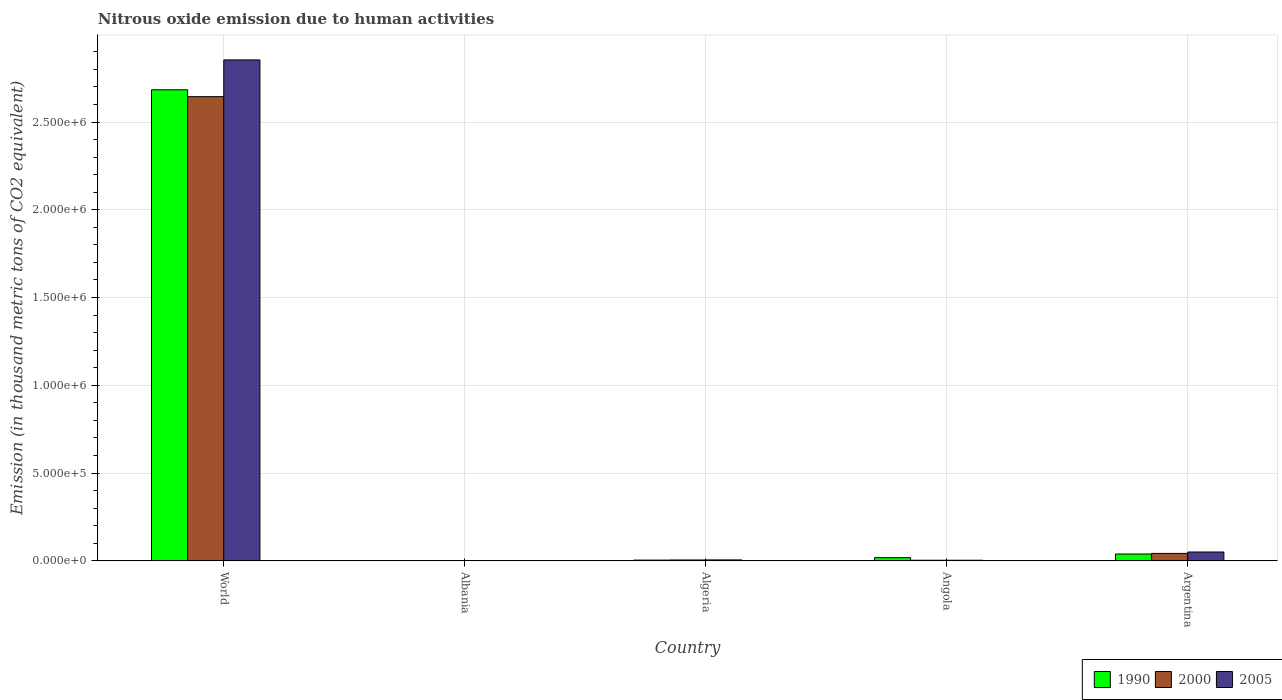How many groups of bars are there?
Offer a terse response. 5. Are the number of bars on each tick of the X-axis equal?
Provide a short and direct response. Yes. How many bars are there on the 3rd tick from the left?
Your answer should be very brief. 3. How many bars are there on the 3rd tick from the right?
Your response must be concise. 3. In how many cases, is the number of bars for a given country not equal to the number of legend labels?
Give a very brief answer. 0. What is the amount of nitrous oxide emitted in 1990 in Algeria?
Offer a terse response. 3867.6. Across all countries, what is the maximum amount of nitrous oxide emitted in 2005?
Offer a terse response. 2.85e+06. Across all countries, what is the minimum amount of nitrous oxide emitted in 2000?
Keep it short and to the point. 1270.7. In which country was the amount of nitrous oxide emitted in 2000 maximum?
Make the answer very short. World. In which country was the amount of nitrous oxide emitted in 1990 minimum?
Make the answer very short. Albania. What is the total amount of nitrous oxide emitted in 1990 in the graph?
Provide a short and direct response. 2.75e+06. What is the difference between the amount of nitrous oxide emitted in 2005 in Argentina and that in World?
Offer a terse response. -2.80e+06. What is the difference between the amount of nitrous oxide emitted in 1990 in Argentina and the amount of nitrous oxide emitted in 2005 in Angola?
Give a very brief answer. 3.54e+04. What is the average amount of nitrous oxide emitted in 2005 per country?
Keep it short and to the point. 5.83e+05. What is the difference between the amount of nitrous oxide emitted of/in 2005 and amount of nitrous oxide emitted of/in 2000 in Argentina?
Offer a terse response. 8004.7. In how many countries, is the amount of nitrous oxide emitted in 2000 greater than 2000000 thousand metric tons?
Ensure brevity in your answer.  1. What is the ratio of the amount of nitrous oxide emitted in 2005 in Albania to that in Angola?
Your response must be concise. 0.34. What is the difference between the highest and the second highest amount of nitrous oxide emitted in 2000?
Offer a very short reply. 2.64e+06. What is the difference between the highest and the lowest amount of nitrous oxide emitted in 1990?
Your answer should be compact. 2.68e+06. What does the 3rd bar from the left in Albania represents?
Make the answer very short. 2005. Is it the case that in every country, the sum of the amount of nitrous oxide emitted in 2000 and amount of nitrous oxide emitted in 1990 is greater than the amount of nitrous oxide emitted in 2005?
Provide a succinct answer. Yes. How many bars are there?
Your answer should be very brief. 15. Does the graph contain grids?
Provide a short and direct response. Yes. How many legend labels are there?
Offer a very short reply. 3. How are the legend labels stacked?
Your response must be concise. Horizontal. What is the title of the graph?
Ensure brevity in your answer.  Nitrous oxide emission due to human activities. What is the label or title of the Y-axis?
Your response must be concise. Emission (in thousand metric tons of CO2 equivalent). What is the Emission (in thousand metric tons of CO2 equivalent) of 1990 in World?
Your response must be concise. 2.68e+06. What is the Emission (in thousand metric tons of CO2 equivalent) in 2000 in World?
Provide a short and direct response. 2.64e+06. What is the Emission (in thousand metric tons of CO2 equivalent) of 2005 in World?
Your response must be concise. 2.85e+06. What is the Emission (in thousand metric tons of CO2 equivalent) in 1990 in Albania?
Your answer should be very brief. 1276.4. What is the Emission (in thousand metric tons of CO2 equivalent) of 2000 in Albania?
Your response must be concise. 1270.7. What is the Emission (in thousand metric tons of CO2 equivalent) of 2005 in Albania?
Your answer should be compact. 1039.6. What is the Emission (in thousand metric tons of CO2 equivalent) of 1990 in Algeria?
Provide a short and direct response. 3867.6. What is the Emission (in thousand metric tons of CO2 equivalent) of 2000 in Algeria?
Offer a terse response. 4507.1. What is the Emission (in thousand metric tons of CO2 equivalent) of 2005 in Algeria?
Your answer should be compact. 4917. What is the Emission (in thousand metric tons of CO2 equivalent) of 1990 in Angola?
Give a very brief answer. 1.77e+04. What is the Emission (in thousand metric tons of CO2 equivalent) in 2000 in Angola?
Your answer should be very brief. 3005.3. What is the Emission (in thousand metric tons of CO2 equivalent) of 2005 in Angola?
Keep it short and to the point. 3056.7. What is the Emission (in thousand metric tons of CO2 equivalent) of 1990 in Argentina?
Make the answer very short. 3.85e+04. What is the Emission (in thousand metric tons of CO2 equivalent) in 2000 in Argentina?
Offer a terse response. 4.20e+04. What is the Emission (in thousand metric tons of CO2 equivalent) in 2005 in Argentina?
Provide a short and direct response. 5.00e+04. Across all countries, what is the maximum Emission (in thousand metric tons of CO2 equivalent) of 1990?
Make the answer very short. 2.68e+06. Across all countries, what is the maximum Emission (in thousand metric tons of CO2 equivalent) of 2000?
Your response must be concise. 2.64e+06. Across all countries, what is the maximum Emission (in thousand metric tons of CO2 equivalent) of 2005?
Provide a succinct answer. 2.85e+06. Across all countries, what is the minimum Emission (in thousand metric tons of CO2 equivalent) of 1990?
Ensure brevity in your answer.  1276.4. Across all countries, what is the minimum Emission (in thousand metric tons of CO2 equivalent) in 2000?
Your answer should be compact. 1270.7. Across all countries, what is the minimum Emission (in thousand metric tons of CO2 equivalent) in 2005?
Give a very brief answer. 1039.6. What is the total Emission (in thousand metric tons of CO2 equivalent) in 1990 in the graph?
Your answer should be compact. 2.75e+06. What is the total Emission (in thousand metric tons of CO2 equivalent) in 2000 in the graph?
Your answer should be very brief. 2.70e+06. What is the total Emission (in thousand metric tons of CO2 equivalent) in 2005 in the graph?
Ensure brevity in your answer.  2.91e+06. What is the difference between the Emission (in thousand metric tons of CO2 equivalent) in 1990 in World and that in Albania?
Provide a short and direct response. 2.68e+06. What is the difference between the Emission (in thousand metric tons of CO2 equivalent) of 2000 in World and that in Albania?
Offer a terse response. 2.64e+06. What is the difference between the Emission (in thousand metric tons of CO2 equivalent) in 2005 in World and that in Albania?
Offer a very short reply. 2.85e+06. What is the difference between the Emission (in thousand metric tons of CO2 equivalent) of 1990 in World and that in Algeria?
Provide a short and direct response. 2.68e+06. What is the difference between the Emission (in thousand metric tons of CO2 equivalent) of 2000 in World and that in Algeria?
Give a very brief answer. 2.64e+06. What is the difference between the Emission (in thousand metric tons of CO2 equivalent) of 2005 in World and that in Algeria?
Provide a short and direct response. 2.85e+06. What is the difference between the Emission (in thousand metric tons of CO2 equivalent) in 1990 in World and that in Angola?
Your answer should be very brief. 2.67e+06. What is the difference between the Emission (in thousand metric tons of CO2 equivalent) in 2000 in World and that in Angola?
Ensure brevity in your answer.  2.64e+06. What is the difference between the Emission (in thousand metric tons of CO2 equivalent) in 2005 in World and that in Angola?
Your answer should be compact. 2.85e+06. What is the difference between the Emission (in thousand metric tons of CO2 equivalent) of 1990 in World and that in Argentina?
Provide a succinct answer. 2.65e+06. What is the difference between the Emission (in thousand metric tons of CO2 equivalent) of 2000 in World and that in Argentina?
Your response must be concise. 2.60e+06. What is the difference between the Emission (in thousand metric tons of CO2 equivalent) in 2005 in World and that in Argentina?
Keep it short and to the point. 2.80e+06. What is the difference between the Emission (in thousand metric tons of CO2 equivalent) in 1990 in Albania and that in Algeria?
Offer a terse response. -2591.2. What is the difference between the Emission (in thousand metric tons of CO2 equivalent) of 2000 in Albania and that in Algeria?
Keep it short and to the point. -3236.4. What is the difference between the Emission (in thousand metric tons of CO2 equivalent) in 2005 in Albania and that in Algeria?
Keep it short and to the point. -3877.4. What is the difference between the Emission (in thousand metric tons of CO2 equivalent) in 1990 in Albania and that in Angola?
Your answer should be very brief. -1.65e+04. What is the difference between the Emission (in thousand metric tons of CO2 equivalent) in 2000 in Albania and that in Angola?
Ensure brevity in your answer.  -1734.6. What is the difference between the Emission (in thousand metric tons of CO2 equivalent) in 2005 in Albania and that in Angola?
Make the answer very short. -2017.1. What is the difference between the Emission (in thousand metric tons of CO2 equivalent) in 1990 in Albania and that in Argentina?
Ensure brevity in your answer.  -3.72e+04. What is the difference between the Emission (in thousand metric tons of CO2 equivalent) of 2000 in Albania and that in Argentina?
Your response must be concise. -4.07e+04. What is the difference between the Emission (in thousand metric tons of CO2 equivalent) in 2005 in Albania and that in Argentina?
Your answer should be very brief. -4.89e+04. What is the difference between the Emission (in thousand metric tons of CO2 equivalent) in 1990 in Algeria and that in Angola?
Your answer should be very brief. -1.39e+04. What is the difference between the Emission (in thousand metric tons of CO2 equivalent) of 2000 in Algeria and that in Angola?
Keep it short and to the point. 1501.8. What is the difference between the Emission (in thousand metric tons of CO2 equivalent) of 2005 in Algeria and that in Angola?
Offer a terse response. 1860.3. What is the difference between the Emission (in thousand metric tons of CO2 equivalent) of 1990 in Algeria and that in Argentina?
Your answer should be compact. -3.46e+04. What is the difference between the Emission (in thousand metric tons of CO2 equivalent) in 2000 in Algeria and that in Argentina?
Your answer should be compact. -3.74e+04. What is the difference between the Emission (in thousand metric tons of CO2 equivalent) of 2005 in Algeria and that in Argentina?
Your response must be concise. -4.50e+04. What is the difference between the Emission (in thousand metric tons of CO2 equivalent) of 1990 in Angola and that in Argentina?
Provide a short and direct response. -2.07e+04. What is the difference between the Emission (in thousand metric tons of CO2 equivalent) in 2000 in Angola and that in Argentina?
Provide a short and direct response. -3.89e+04. What is the difference between the Emission (in thousand metric tons of CO2 equivalent) in 2005 in Angola and that in Argentina?
Ensure brevity in your answer.  -4.69e+04. What is the difference between the Emission (in thousand metric tons of CO2 equivalent) in 1990 in World and the Emission (in thousand metric tons of CO2 equivalent) in 2000 in Albania?
Keep it short and to the point. 2.68e+06. What is the difference between the Emission (in thousand metric tons of CO2 equivalent) of 1990 in World and the Emission (in thousand metric tons of CO2 equivalent) of 2005 in Albania?
Ensure brevity in your answer.  2.68e+06. What is the difference between the Emission (in thousand metric tons of CO2 equivalent) in 2000 in World and the Emission (in thousand metric tons of CO2 equivalent) in 2005 in Albania?
Keep it short and to the point. 2.64e+06. What is the difference between the Emission (in thousand metric tons of CO2 equivalent) in 1990 in World and the Emission (in thousand metric tons of CO2 equivalent) in 2000 in Algeria?
Offer a very short reply. 2.68e+06. What is the difference between the Emission (in thousand metric tons of CO2 equivalent) in 1990 in World and the Emission (in thousand metric tons of CO2 equivalent) in 2005 in Algeria?
Offer a terse response. 2.68e+06. What is the difference between the Emission (in thousand metric tons of CO2 equivalent) of 2000 in World and the Emission (in thousand metric tons of CO2 equivalent) of 2005 in Algeria?
Your answer should be very brief. 2.64e+06. What is the difference between the Emission (in thousand metric tons of CO2 equivalent) of 1990 in World and the Emission (in thousand metric tons of CO2 equivalent) of 2000 in Angola?
Give a very brief answer. 2.68e+06. What is the difference between the Emission (in thousand metric tons of CO2 equivalent) in 1990 in World and the Emission (in thousand metric tons of CO2 equivalent) in 2005 in Angola?
Your response must be concise. 2.68e+06. What is the difference between the Emission (in thousand metric tons of CO2 equivalent) of 2000 in World and the Emission (in thousand metric tons of CO2 equivalent) of 2005 in Angola?
Provide a short and direct response. 2.64e+06. What is the difference between the Emission (in thousand metric tons of CO2 equivalent) in 1990 in World and the Emission (in thousand metric tons of CO2 equivalent) in 2000 in Argentina?
Make the answer very short. 2.64e+06. What is the difference between the Emission (in thousand metric tons of CO2 equivalent) in 1990 in World and the Emission (in thousand metric tons of CO2 equivalent) in 2005 in Argentina?
Ensure brevity in your answer.  2.63e+06. What is the difference between the Emission (in thousand metric tons of CO2 equivalent) of 2000 in World and the Emission (in thousand metric tons of CO2 equivalent) of 2005 in Argentina?
Your response must be concise. 2.59e+06. What is the difference between the Emission (in thousand metric tons of CO2 equivalent) of 1990 in Albania and the Emission (in thousand metric tons of CO2 equivalent) of 2000 in Algeria?
Provide a short and direct response. -3230.7. What is the difference between the Emission (in thousand metric tons of CO2 equivalent) of 1990 in Albania and the Emission (in thousand metric tons of CO2 equivalent) of 2005 in Algeria?
Your response must be concise. -3640.6. What is the difference between the Emission (in thousand metric tons of CO2 equivalent) in 2000 in Albania and the Emission (in thousand metric tons of CO2 equivalent) in 2005 in Algeria?
Give a very brief answer. -3646.3. What is the difference between the Emission (in thousand metric tons of CO2 equivalent) of 1990 in Albania and the Emission (in thousand metric tons of CO2 equivalent) of 2000 in Angola?
Provide a short and direct response. -1728.9. What is the difference between the Emission (in thousand metric tons of CO2 equivalent) in 1990 in Albania and the Emission (in thousand metric tons of CO2 equivalent) in 2005 in Angola?
Ensure brevity in your answer.  -1780.3. What is the difference between the Emission (in thousand metric tons of CO2 equivalent) in 2000 in Albania and the Emission (in thousand metric tons of CO2 equivalent) in 2005 in Angola?
Give a very brief answer. -1786. What is the difference between the Emission (in thousand metric tons of CO2 equivalent) of 1990 in Albania and the Emission (in thousand metric tons of CO2 equivalent) of 2000 in Argentina?
Your answer should be very brief. -4.07e+04. What is the difference between the Emission (in thousand metric tons of CO2 equivalent) of 1990 in Albania and the Emission (in thousand metric tons of CO2 equivalent) of 2005 in Argentina?
Make the answer very short. -4.87e+04. What is the difference between the Emission (in thousand metric tons of CO2 equivalent) in 2000 in Albania and the Emission (in thousand metric tons of CO2 equivalent) in 2005 in Argentina?
Ensure brevity in your answer.  -4.87e+04. What is the difference between the Emission (in thousand metric tons of CO2 equivalent) of 1990 in Algeria and the Emission (in thousand metric tons of CO2 equivalent) of 2000 in Angola?
Offer a terse response. 862.3. What is the difference between the Emission (in thousand metric tons of CO2 equivalent) of 1990 in Algeria and the Emission (in thousand metric tons of CO2 equivalent) of 2005 in Angola?
Ensure brevity in your answer.  810.9. What is the difference between the Emission (in thousand metric tons of CO2 equivalent) of 2000 in Algeria and the Emission (in thousand metric tons of CO2 equivalent) of 2005 in Angola?
Provide a short and direct response. 1450.4. What is the difference between the Emission (in thousand metric tons of CO2 equivalent) in 1990 in Algeria and the Emission (in thousand metric tons of CO2 equivalent) in 2000 in Argentina?
Your response must be concise. -3.81e+04. What is the difference between the Emission (in thousand metric tons of CO2 equivalent) in 1990 in Algeria and the Emission (in thousand metric tons of CO2 equivalent) in 2005 in Argentina?
Provide a succinct answer. -4.61e+04. What is the difference between the Emission (in thousand metric tons of CO2 equivalent) in 2000 in Algeria and the Emission (in thousand metric tons of CO2 equivalent) in 2005 in Argentina?
Offer a terse response. -4.54e+04. What is the difference between the Emission (in thousand metric tons of CO2 equivalent) of 1990 in Angola and the Emission (in thousand metric tons of CO2 equivalent) of 2000 in Argentina?
Provide a short and direct response. -2.42e+04. What is the difference between the Emission (in thousand metric tons of CO2 equivalent) of 1990 in Angola and the Emission (in thousand metric tons of CO2 equivalent) of 2005 in Argentina?
Your answer should be very brief. -3.22e+04. What is the difference between the Emission (in thousand metric tons of CO2 equivalent) in 2000 in Angola and the Emission (in thousand metric tons of CO2 equivalent) in 2005 in Argentina?
Your response must be concise. -4.70e+04. What is the average Emission (in thousand metric tons of CO2 equivalent) in 1990 per country?
Ensure brevity in your answer.  5.49e+05. What is the average Emission (in thousand metric tons of CO2 equivalent) in 2000 per country?
Give a very brief answer. 5.39e+05. What is the average Emission (in thousand metric tons of CO2 equivalent) in 2005 per country?
Give a very brief answer. 5.83e+05. What is the difference between the Emission (in thousand metric tons of CO2 equivalent) in 1990 and Emission (in thousand metric tons of CO2 equivalent) in 2000 in World?
Offer a terse response. 3.92e+04. What is the difference between the Emission (in thousand metric tons of CO2 equivalent) in 1990 and Emission (in thousand metric tons of CO2 equivalent) in 2005 in World?
Ensure brevity in your answer.  -1.70e+05. What is the difference between the Emission (in thousand metric tons of CO2 equivalent) of 2000 and Emission (in thousand metric tons of CO2 equivalent) of 2005 in World?
Keep it short and to the point. -2.09e+05. What is the difference between the Emission (in thousand metric tons of CO2 equivalent) of 1990 and Emission (in thousand metric tons of CO2 equivalent) of 2005 in Albania?
Your response must be concise. 236.8. What is the difference between the Emission (in thousand metric tons of CO2 equivalent) in 2000 and Emission (in thousand metric tons of CO2 equivalent) in 2005 in Albania?
Give a very brief answer. 231.1. What is the difference between the Emission (in thousand metric tons of CO2 equivalent) in 1990 and Emission (in thousand metric tons of CO2 equivalent) in 2000 in Algeria?
Your response must be concise. -639.5. What is the difference between the Emission (in thousand metric tons of CO2 equivalent) in 1990 and Emission (in thousand metric tons of CO2 equivalent) in 2005 in Algeria?
Make the answer very short. -1049.4. What is the difference between the Emission (in thousand metric tons of CO2 equivalent) of 2000 and Emission (in thousand metric tons of CO2 equivalent) of 2005 in Algeria?
Your answer should be compact. -409.9. What is the difference between the Emission (in thousand metric tons of CO2 equivalent) of 1990 and Emission (in thousand metric tons of CO2 equivalent) of 2000 in Angola?
Offer a terse response. 1.47e+04. What is the difference between the Emission (in thousand metric tons of CO2 equivalent) in 1990 and Emission (in thousand metric tons of CO2 equivalent) in 2005 in Angola?
Offer a terse response. 1.47e+04. What is the difference between the Emission (in thousand metric tons of CO2 equivalent) of 2000 and Emission (in thousand metric tons of CO2 equivalent) of 2005 in Angola?
Your answer should be compact. -51.4. What is the difference between the Emission (in thousand metric tons of CO2 equivalent) in 1990 and Emission (in thousand metric tons of CO2 equivalent) in 2000 in Argentina?
Keep it short and to the point. -3498.7. What is the difference between the Emission (in thousand metric tons of CO2 equivalent) in 1990 and Emission (in thousand metric tons of CO2 equivalent) in 2005 in Argentina?
Offer a very short reply. -1.15e+04. What is the difference between the Emission (in thousand metric tons of CO2 equivalent) of 2000 and Emission (in thousand metric tons of CO2 equivalent) of 2005 in Argentina?
Ensure brevity in your answer.  -8004.7. What is the ratio of the Emission (in thousand metric tons of CO2 equivalent) of 1990 in World to that in Albania?
Give a very brief answer. 2102.65. What is the ratio of the Emission (in thousand metric tons of CO2 equivalent) of 2000 in World to that in Albania?
Provide a short and direct response. 2081.22. What is the ratio of the Emission (in thousand metric tons of CO2 equivalent) of 2005 in World to that in Albania?
Provide a succinct answer. 2745.21. What is the ratio of the Emission (in thousand metric tons of CO2 equivalent) in 1990 in World to that in Algeria?
Ensure brevity in your answer.  693.92. What is the ratio of the Emission (in thousand metric tons of CO2 equivalent) of 2000 in World to that in Algeria?
Ensure brevity in your answer.  586.76. What is the ratio of the Emission (in thousand metric tons of CO2 equivalent) of 2005 in World to that in Algeria?
Give a very brief answer. 580.42. What is the ratio of the Emission (in thousand metric tons of CO2 equivalent) in 1990 in World to that in Angola?
Provide a succinct answer. 151.34. What is the ratio of the Emission (in thousand metric tons of CO2 equivalent) in 2000 in World to that in Angola?
Offer a terse response. 879.98. What is the ratio of the Emission (in thousand metric tons of CO2 equivalent) of 2005 in World to that in Angola?
Offer a terse response. 933.66. What is the ratio of the Emission (in thousand metric tons of CO2 equivalent) in 1990 in World to that in Argentina?
Keep it short and to the point. 69.79. What is the ratio of the Emission (in thousand metric tons of CO2 equivalent) of 2000 in World to that in Argentina?
Keep it short and to the point. 63.04. What is the ratio of the Emission (in thousand metric tons of CO2 equivalent) of 2005 in World to that in Argentina?
Offer a very short reply. 57.13. What is the ratio of the Emission (in thousand metric tons of CO2 equivalent) in 1990 in Albania to that in Algeria?
Your response must be concise. 0.33. What is the ratio of the Emission (in thousand metric tons of CO2 equivalent) in 2000 in Albania to that in Algeria?
Offer a terse response. 0.28. What is the ratio of the Emission (in thousand metric tons of CO2 equivalent) in 2005 in Albania to that in Algeria?
Provide a succinct answer. 0.21. What is the ratio of the Emission (in thousand metric tons of CO2 equivalent) in 1990 in Albania to that in Angola?
Offer a terse response. 0.07. What is the ratio of the Emission (in thousand metric tons of CO2 equivalent) in 2000 in Albania to that in Angola?
Offer a very short reply. 0.42. What is the ratio of the Emission (in thousand metric tons of CO2 equivalent) in 2005 in Albania to that in Angola?
Provide a short and direct response. 0.34. What is the ratio of the Emission (in thousand metric tons of CO2 equivalent) of 1990 in Albania to that in Argentina?
Your response must be concise. 0.03. What is the ratio of the Emission (in thousand metric tons of CO2 equivalent) in 2000 in Albania to that in Argentina?
Offer a very short reply. 0.03. What is the ratio of the Emission (in thousand metric tons of CO2 equivalent) in 2005 in Albania to that in Argentina?
Offer a terse response. 0.02. What is the ratio of the Emission (in thousand metric tons of CO2 equivalent) of 1990 in Algeria to that in Angola?
Ensure brevity in your answer.  0.22. What is the ratio of the Emission (in thousand metric tons of CO2 equivalent) of 2000 in Algeria to that in Angola?
Offer a terse response. 1.5. What is the ratio of the Emission (in thousand metric tons of CO2 equivalent) of 2005 in Algeria to that in Angola?
Your answer should be compact. 1.61. What is the ratio of the Emission (in thousand metric tons of CO2 equivalent) in 1990 in Algeria to that in Argentina?
Ensure brevity in your answer.  0.1. What is the ratio of the Emission (in thousand metric tons of CO2 equivalent) in 2000 in Algeria to that in Argentina?
Give a very brief answer. 0.11. What is the ratio of the Emission (in thousand metric tons of CO2 equivalent) in 2005 in Algeria to that in Argentina?
Provide a short and direct response. 0.1. What is the ratio of the Emission (in thousand metric tons of CO2 equivalent) of 1990 in Angola to that in Argentina?
Your answer should be very brief. 0.46. What is the ratio of the Emission (in thousand metric tons of CO2 equivalent) of 2000 in Angola to that in Argentina?
Provide a short and direct response. 0.07. What is the ratio of the Emission (in thousand metric tons of CO2 equivalent) of 2005 in Angola to that in Argentina?
Make the answer very short. 0.06. What is the difference between the highest and the second highest Emission (in thousand metric tons of CO2 equivalent) in 1990?
Your answer should be very brief. 2.65e+06. What is the difference between the highest and the second highest Emission (in thousand metric tons of CO2 equivalent) in 2000?
Keep it short and to the point. 2.60e+06. What is the difference between the highest and the second highest Emission (in thousand metric tons of CO2 equivalent) of 2005?
Make the answer very short. 2.80e+06. What is the difference between the highest and the lowest Emission (in thousand metric tons of CO2 equivalent) of 1990?
Provide a short and direct response. 2.68e+06. What is the difference between the highest and the lowest Emission (in thousand metric tons of CO2 equivalent) in 2000?
Keep it short and to the point. 2.64e+06. What is the difference between the highest and the lowest Emission (in thousand metric tons of CO2 equivalent) of 2005?
Provide a short and direct response. 2.85e+06. 